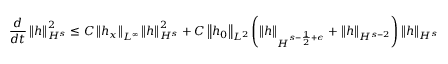Convert formula to latex. <formula><loc_0><loc_0><loc_500><loc_500>\frac { d } { d t } \left \| h \right \| _ { H ^ { s } } ^ { 2 } \leq C \left \| h _ { x } \right \| _ { L ^ { \infty } } \left \| h \right \| _ { H ^ { s } } ^ { 2 } + C \left \| h _ { 0 } \right \| _ { L ^ { 2 } } \left ( \left \| h \right \| _ { H ^ { s - \frac { 1 } { 2 } + \epsilon } } + \left \| h \right \| _ { H ^ { s - 2 } } \right ) \left \| h \right \| _ { H ^ { s } }</formula> 